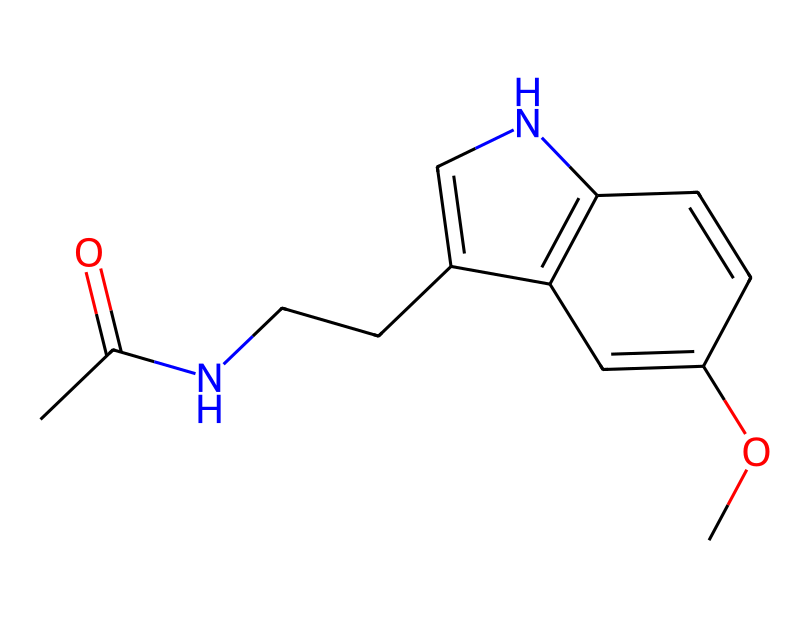What is the name of this chemical? The SMILES representation corresponds to melatonin, a well-known hormone involved in regulating sleep cycles.
Answer: melatonin How many rings are present in this chemical structure? Analyzing the structure reveals there are two fused aromatic rings, characteristic of the indole structure in melatonin.
Answer: 2 What is the molecular formula of melatonin based on the chemical structure? By counting the atoms present, it can be derived that the molecular formula is C13H16N2O2.
Answer: C13H16N2O2 What functional groups are present in melatonin? In the structure, there is an acetamide group (from the CC(=O)N) and a methoxy group (from the OC), indicating the presence of amide and ether functionalities.
Answer: amide, ether How many nitrogen atoms are there in this chemical? In the structure, we can identify two nitrogen atoms located within the aromatic rings and the acetamide group.
Answer: 2 What is the main role of melatonin in the body? Melatonin primarily regulates sleep cycles and circadian rhythms, helping coordinate sleep timing with environmental light cues.
Answer: regulate sleep How might melatonin affect workplace productivity? Proper melatonin levels improve sleep quality, which enhances focus and cognitive performance, positively impacting workplace productivity.
Answer: enhance focus 